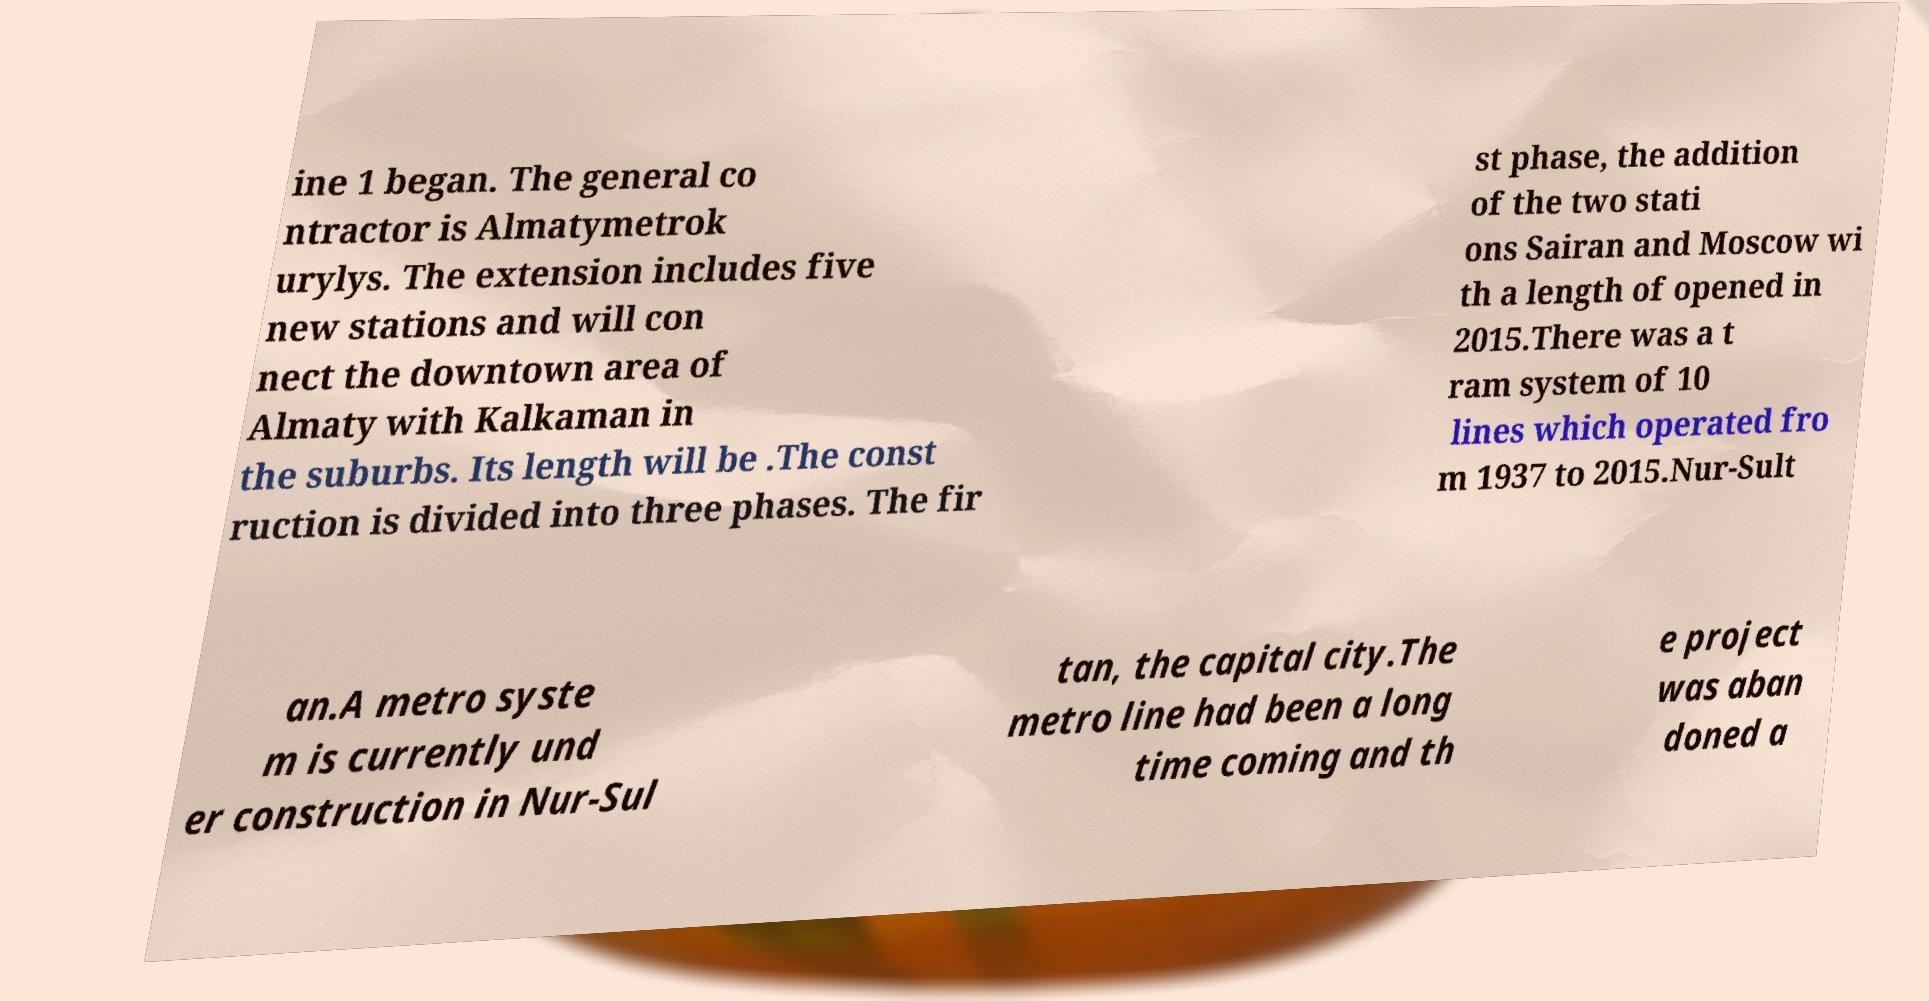Could you extract and type out the text from this image? ine 1 began. The general co ntractor is Almatymetrok urylys. The extension includes five new stations and will con nect the downtown area of Almaty with Kalkaman in the suburbs. Its length will be .The const ruction is divided into three phases. The fir st phase, the addition of the two stati ons Sairan and Moscow wi th a length of opened in 2015.There was a t ram system of 10 lines which operated fro m 1937 to 2015.Nur-Sult an.A metro syste m is currently und er construction in Nur-Sul tan, the capital city.The metro line had been a long time coming and th e project was aban doned a 